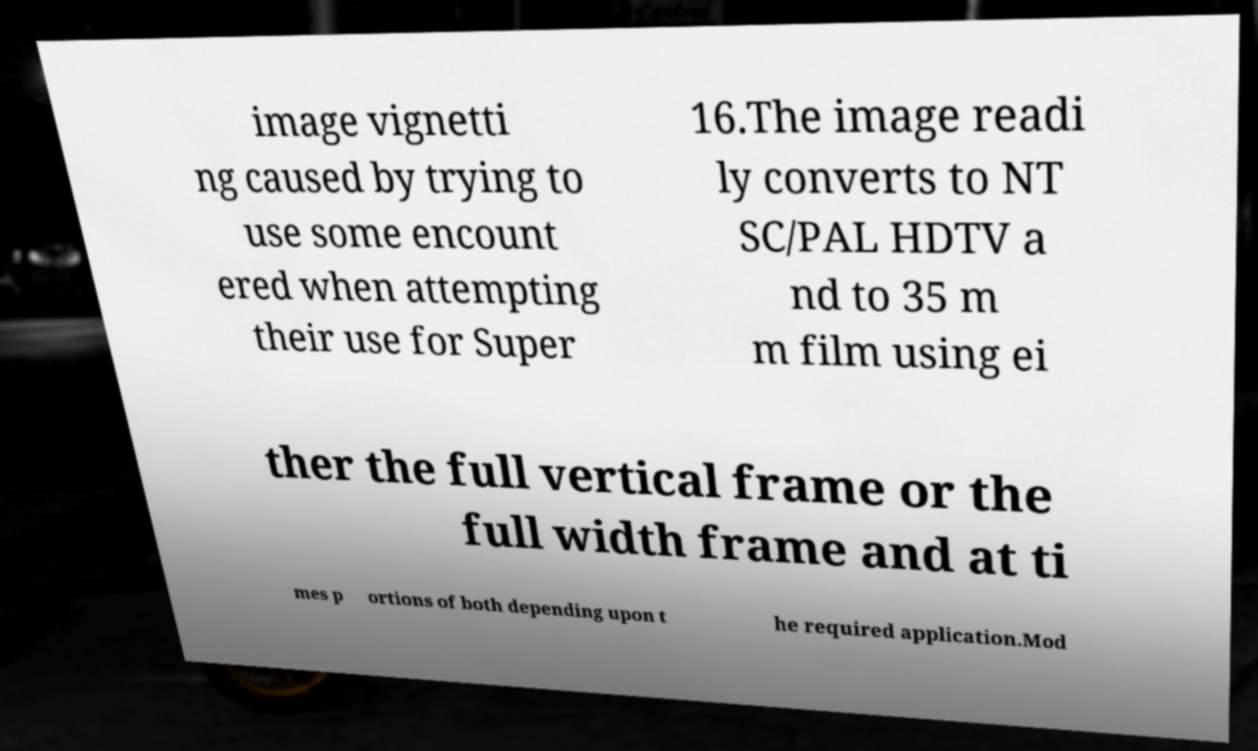Please read and relay the text visible in this image. What does it say? image vignetti ng caused by trying to use some encount ered when attempting their use for Super 16.The image readi ly converts to NT SC/PAL HDTV a nd to 35 m m film using ei ther the full vertical frame or the full width frame and at ti mes p ortions of both depending upon t he required application.Mod 